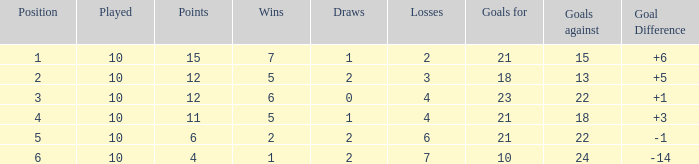Can you inform me of the total count of wins with draws greater than 0, and a points value of 11? 1.0. Write the full table. {'header': ['Position', 'Played', 'Points', 'Wins', 'Draws', 'Losses', 'Goals for', 'Goals against', 'Goal Difference'], 'rows': [['1', '10', '15', '7', '1', '2', '21', '15', '+6'], ['2', '10', '12', '5', '2', '3', '18', '13', '+5'], ['3', '10', '12', '6', '0', '4', '23', '22', '+1'], ['4', '10', '11', '5', '1', '4', '21', '18', '+3'], ['5', '10', '6', '2', '2', '6', '21', '22', '-1'], ['6', '10', '4', '1', '2', '7', '10', '24', '-14']]} 